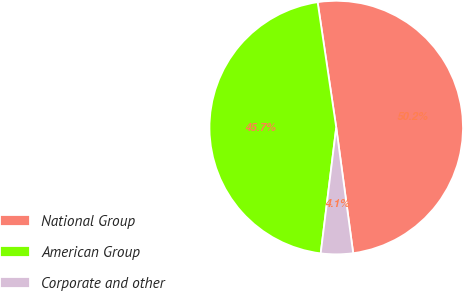<chart> <loc_0><loc_0><loc_500><loc_500><pie_chart><fcel>National Group<fcel>American Group<fcel>Corporate and other<nl><fcel>50.21%<fcel>45.7%<fcel>4.09%<nl></chart> 